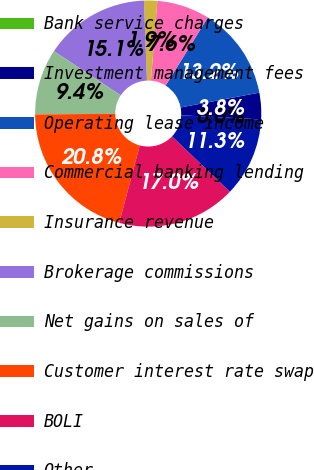<chart> <loc_0><loc_0><loc_500><loc_500><pie_chart><fcel>Bank service charges<fcel>Investment management fees<fcel>Operating lease income<fcel>Commercial banking lending<fcel>Insurance revenue<fcel>Brokerage commissions<fcel>Net gains on sales of<fcel>Customer interest rate swap<fcel>BOLI<fcel>Other<nl><fcel>0.01%<fcel>3.78%<fcel>13.2%<fcel>7.55%<fcel>1.89%<fcel>15.09%<fcel>9.43%<fcel>20.75%<fcel>16.98%<fcel>11.32%<nl></chart> 